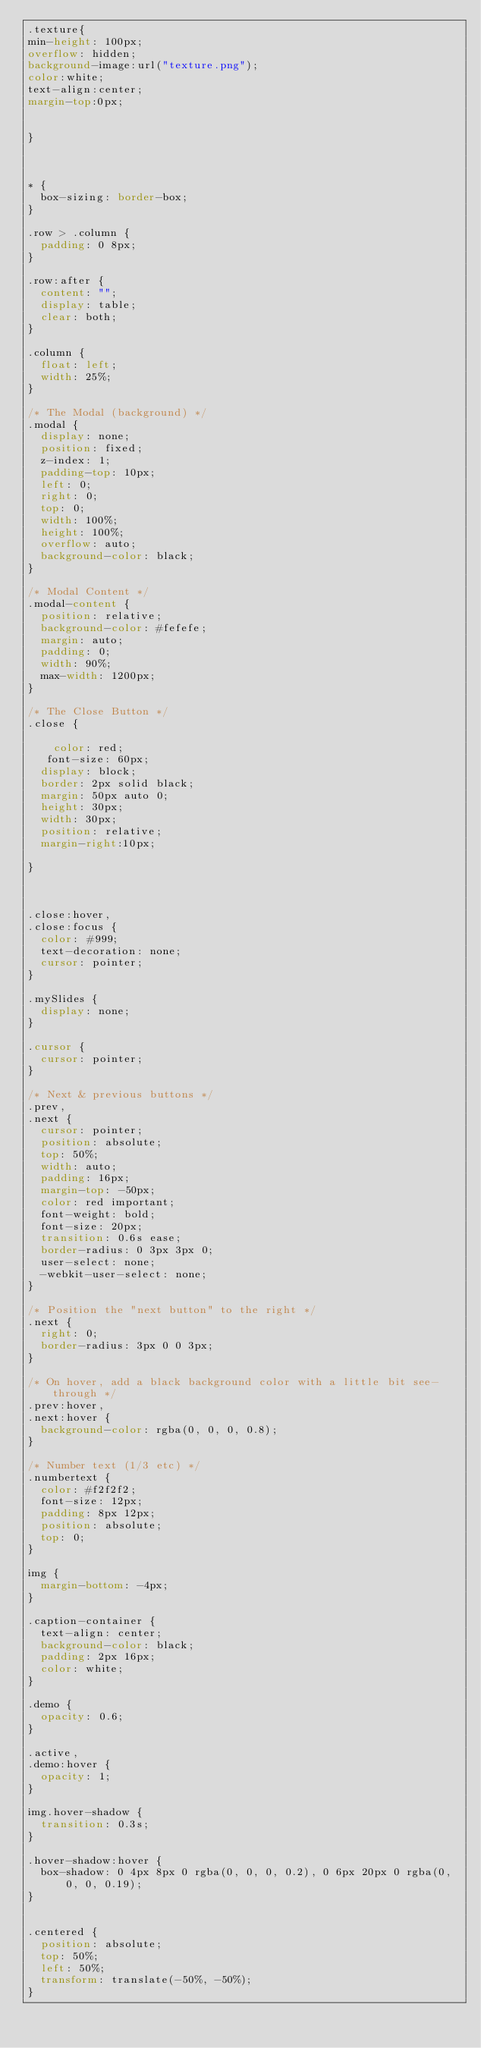<code> <loc_0><loc_0><loc_500><loc_500><_CSS_>.texture{
min-height: 100px;
overflow: hidden;
background-image:url("texture.png");
color:white;
text-align:center;
margin-top:0px;


}



* {
  box-sizing: border-box;
}

.row > .column {
  padding: 0 8px;
}

.row:after {
  content: "";
  display: table;
  clear: both;
}

.column {
  float: left;
  width: 25%;
}

/* The Modal (background) */
.modal {
  display: none;
  position: fixed;
  z-index: 1;
  padding-top: 10px;
  left: 0;
  right: 0;
  top: 0;
  width: 100%;
  height: 100%;
  overflow: auto;
  background-color: black;
}

/* Modal Content */
.modal-content {
  position: relative;
  background-color: #fefefe;
  margin: auto;
  padding: 0;
  width: 90%;
  max-width: 1200px;
}

/* The Close Button */
.close {
	
    color: red;
   font-size: 60px;
  display: block;
  border: 2px solid black;
  margin: 50px auto 0;
  height: 30px;
  width: 30px;
  position: relative;
  margin-right:10px;
	
}
	


.close:hover,
.close:focus {
  color: #999;
  text-decoration: none;
  cursor: pointer;
}

.mySlides {
  display: none;
}

.cursor {
  cursor: pointer;
}

/* Next & previous buttons */
.prev,
.next {
  cursor: pointer;
  position: absolute;
  top: 50%;
  width: auto;
  padding: 16px;
  margin-top: -50px;
  color: red important;
  font-weight: bold;
  font-size: 20px;
  transition: 0.6s ease;
  border-radius: 0 3px 3px 0;
  user-select: none;
  -webkit-user-select: none;
}

/* Position the "next button" to the right */
.next {
  right: 0;
  border-radius: 3px 0 0 3px;
}

/* On hover, add a black background color with a little bit see-through */
.prev:hover,
.next:hover {
  background-color: rgba(0, 0, 0, 0.8);
}

/* Number text (1/3 etc) */
.numbertext {
  color: #f2f2f2;
  font-size: 12px;
  padding: 8px 12px;
  position: absolute;
  top: 0;
}

img {
  margin-bottom: -4px;
}

.caption-container {
  text-align: center;
  background-color: black;
  padding: 2px 16px;
  color: white;
}

.demo {
  opacity: 0.6;
}

.active,
.demo:hover {
  opacity: 1;
}

img.hover-shadow {
  transition: 0.3s;
}

.hover-shadow:hover {
  box-shadow: 0 4px 8px 0 rgba(0, 0, 0, 0.2), 0 6px 20px 0 rgba(0, 0, 0, 0.19);
}


.centered {
  position: absolute;
  top: 50%;
  left: 50%;
  transform: translate(-50%, -50%);
}


</code> 